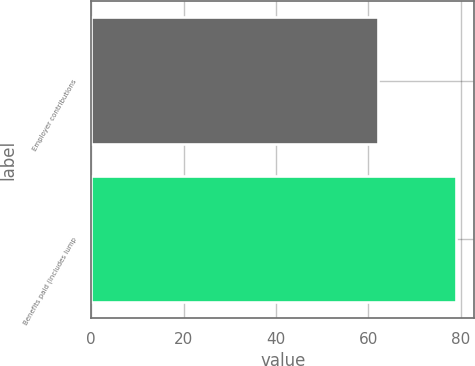Convert chart. <chart><loc_0><loc_0><loc_500><loc_500><bar_chart><fcel>Employer contributions<fcel>Benefits paid (includes lump<nl><fcel>62<fcel>79<nl></chart> 